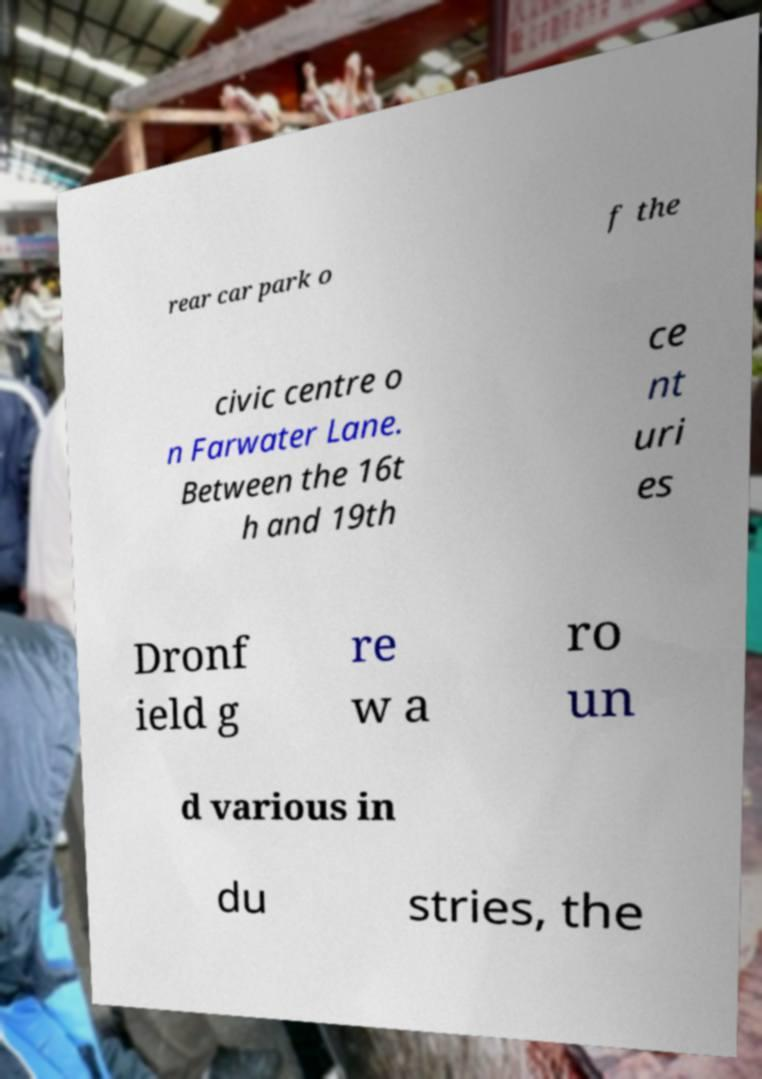Could you extract and type out the text from this image? rear car park o f the civic centre o n Farwater Lane. Between the 16t h and 19th ce nt uri es Dronf ield g re w a ro un d various in du stries, the 